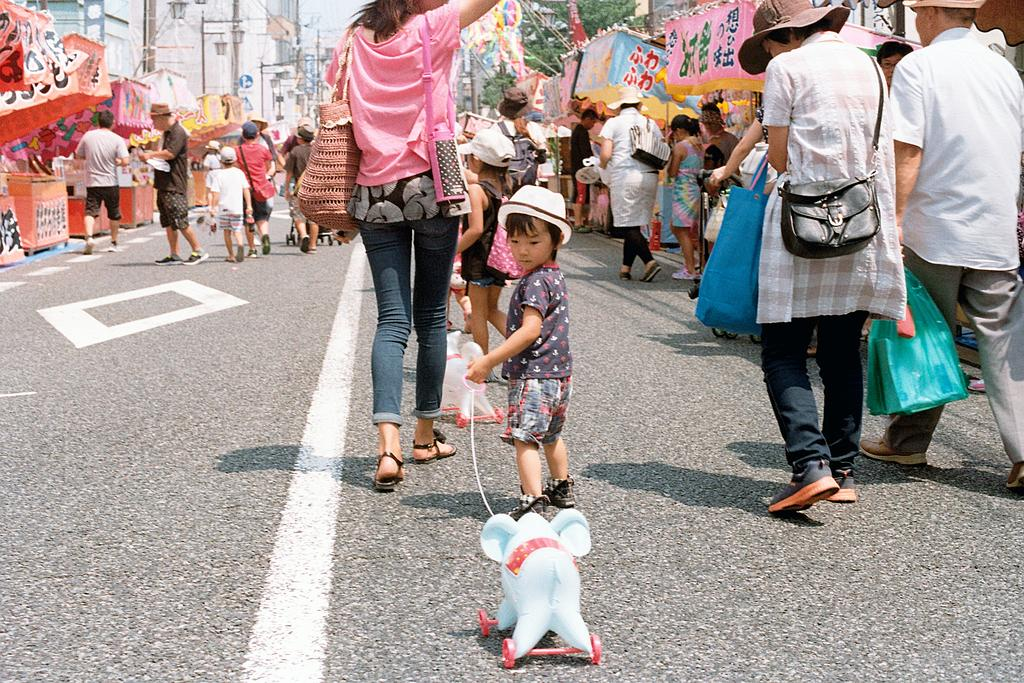What are the people in the image doing? The people in the image are walking on the road. Can you describe the kid in the image? The kid in the image is holding a toy and walking. What can be seen in the background of the image? There are buildings visible in the image. What type of bone can be seen in the image? There is no bone present in the image. Can you describe the mist in the image? There is no mist present in the image. 